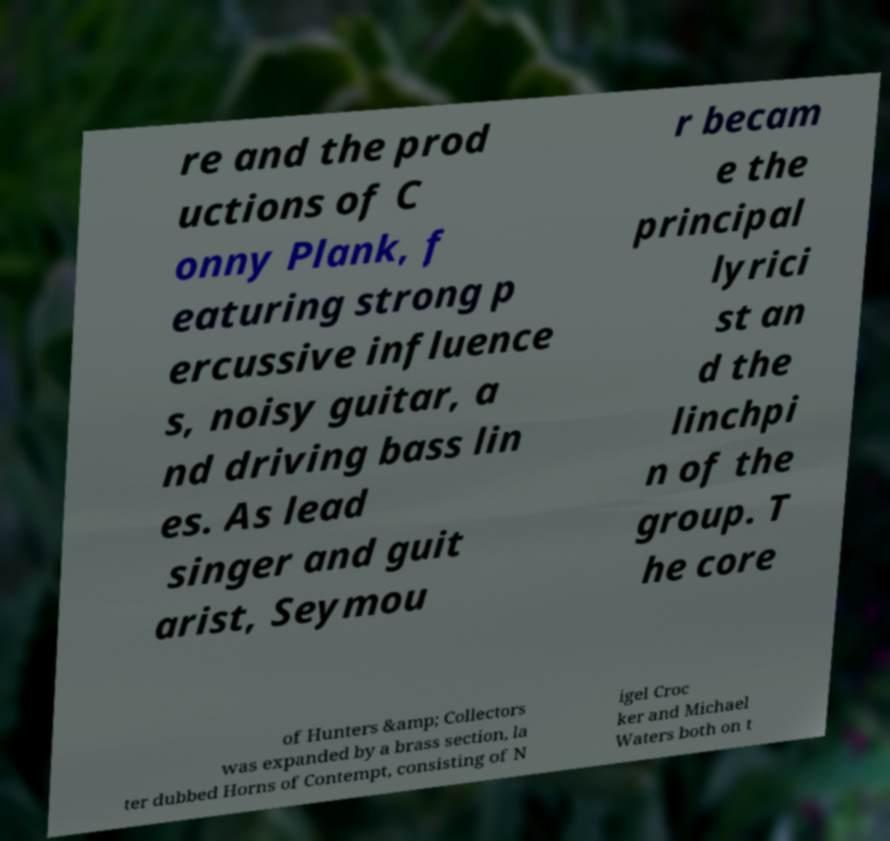Please read and relay the text visible in this image. What does it say? re and the prod uctions of C onny Plank, f eaturing strong p ercussive influence s, noisy guitar, a nd driving bass lin es. As lead singer and guit arist, Seymou r becam e the principal lyrici st an d the linchpi n of the group. T he core of Hunters &amp; Collectors was expanded by a brass section, la ter dubbed Horns of Contempt, consisting of N igel Croc ker and Michael Waters both on t 